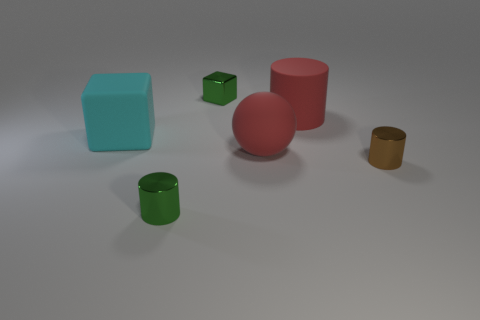What number of large gray shiny things are the same shape as the small brown object?
Make the answer very short. 0. There is a ball that is the same size as the cyan rubber object; what material is it?
Provide a succinct answer. Rubber. How big is the rubber object left of the block right of the cyan thing that is in front of the small shiny cube?
Ensure brevity in your answer.  Large. Does the tiny thing that is on the right side of the red matte cylinder have the same color as the metal cylinder that is on the left side of the sphere?
Your answer should be compact. No. What number of cyan things are either small cylinders or blocks?
Make the answer very short. 1. How many spheres have the same size as the red cylinder?
Ensure brevity in your answer.  1. Do the block behind the big cyan matte cube and the cyan thing have the same material?
Your response must be concise. No. There is a big matte object behind the large cyan matte block; are there any red rubber cylinders that are to the right of it?
Offer a terse response. No. What material is the red object that is the same shape as the brown metal object?
Make the answer very short. Rubber. Are there more matte balls that are to the left of the green block than small metal cubes that are in front of the big red cylinder?
Provide a short and direct response. No. 